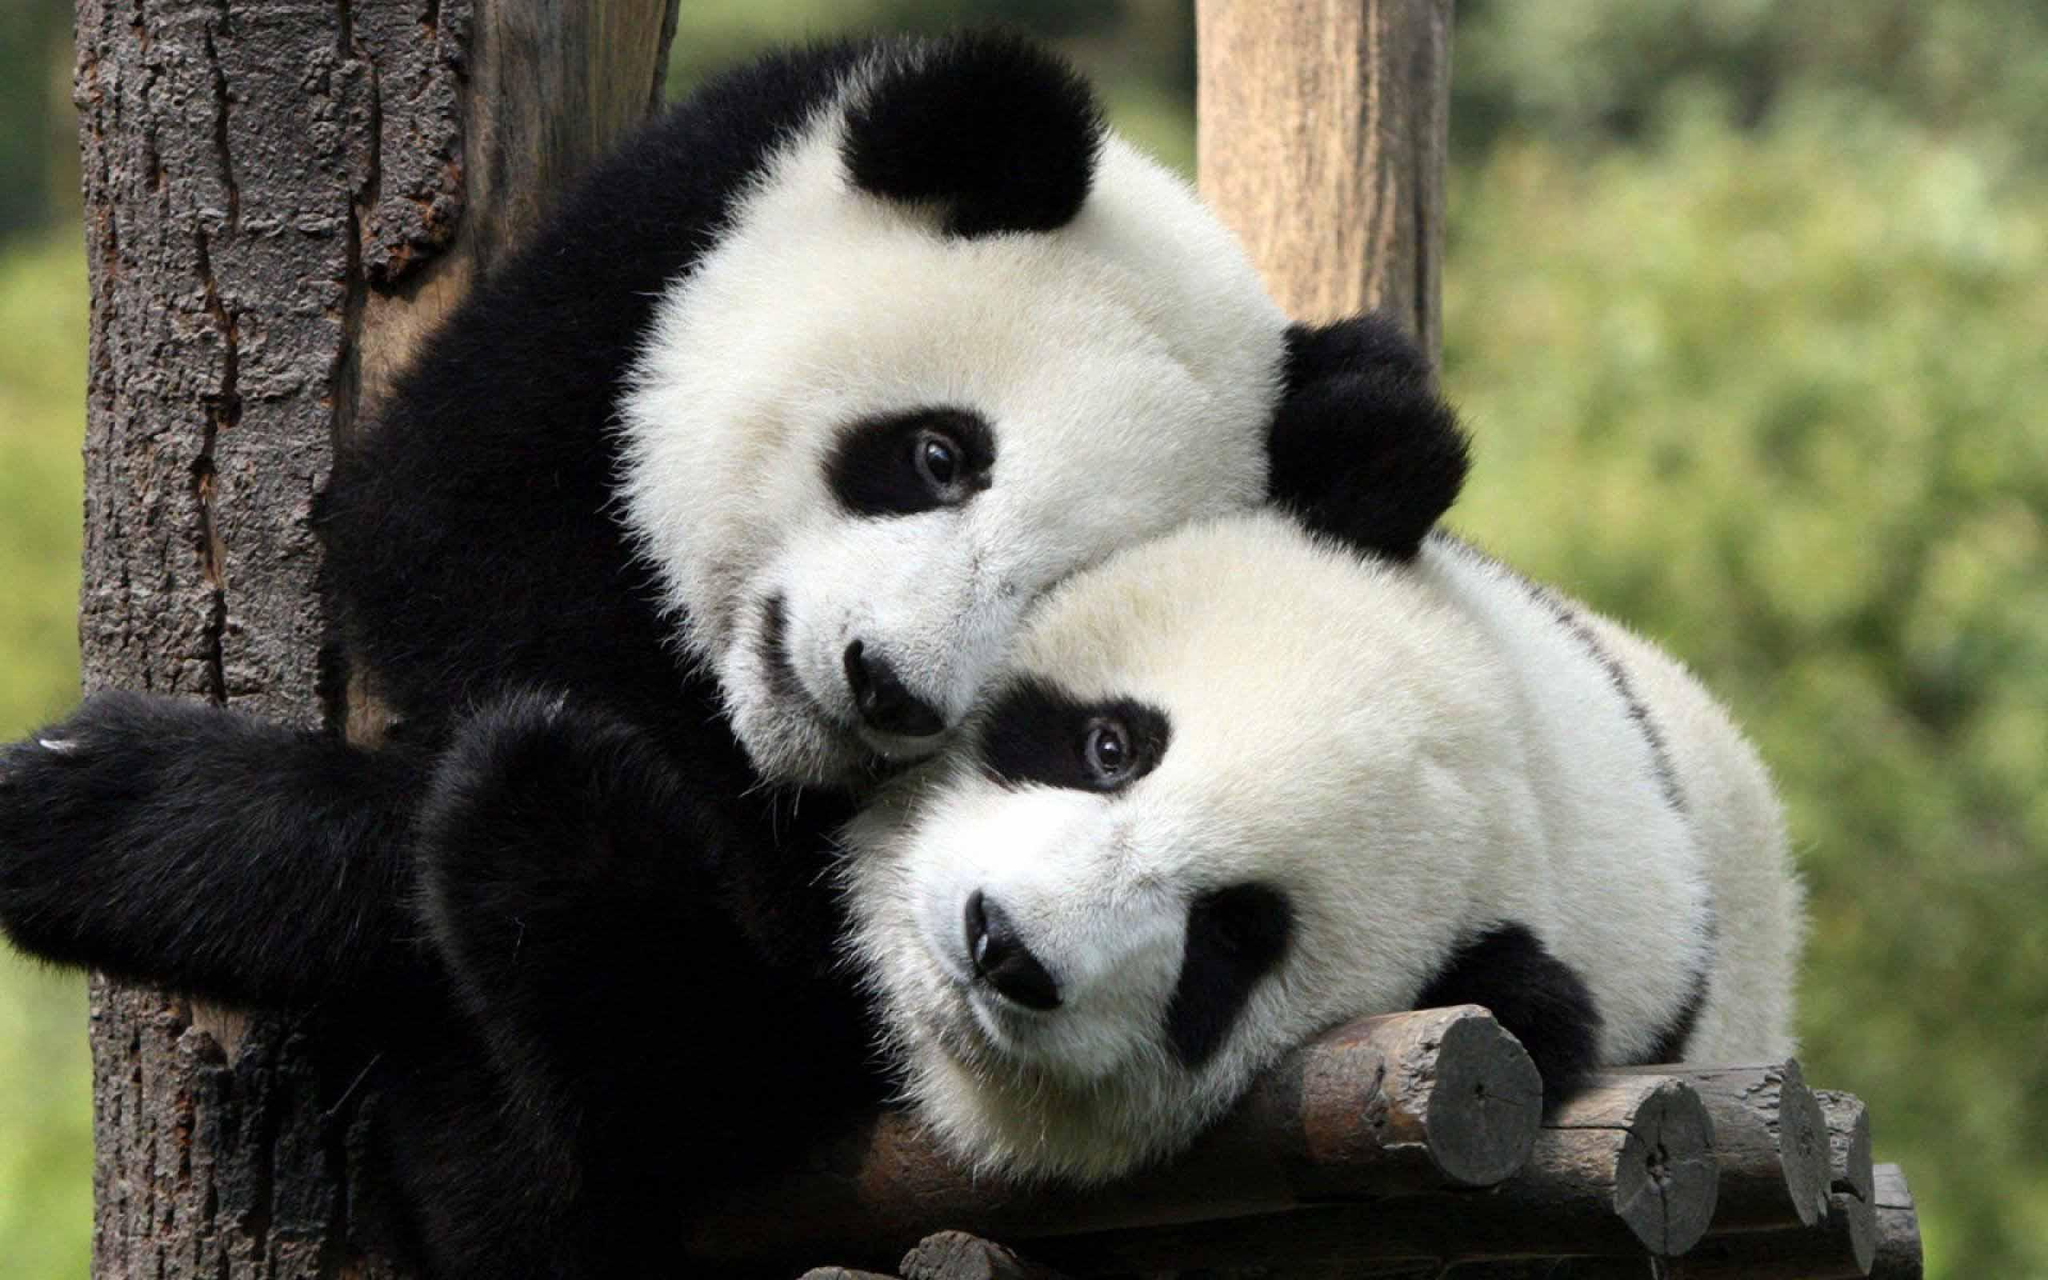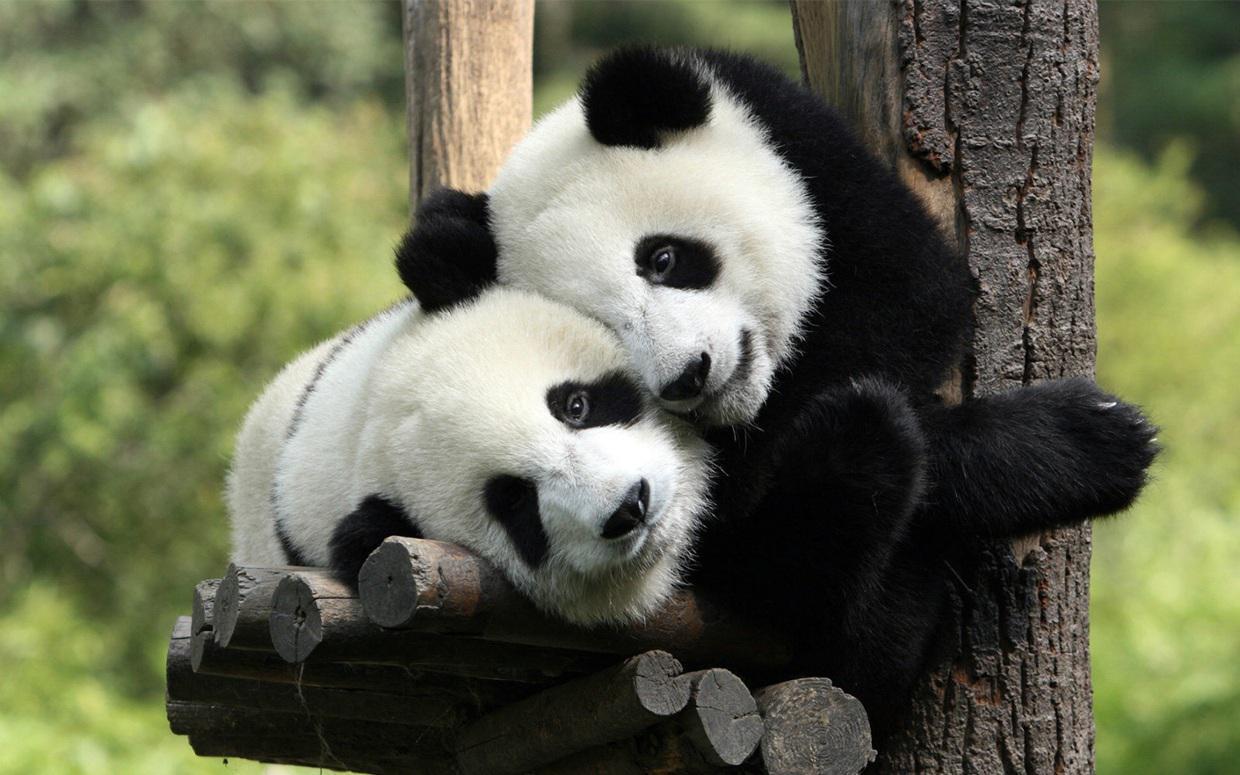The first image is the image on the left, the second image is the image on the right. Assess this claim about the two images: "The panda on the left is nibbling a green stick without leaves on it.". Correct or not? Answer yes or no. No. 